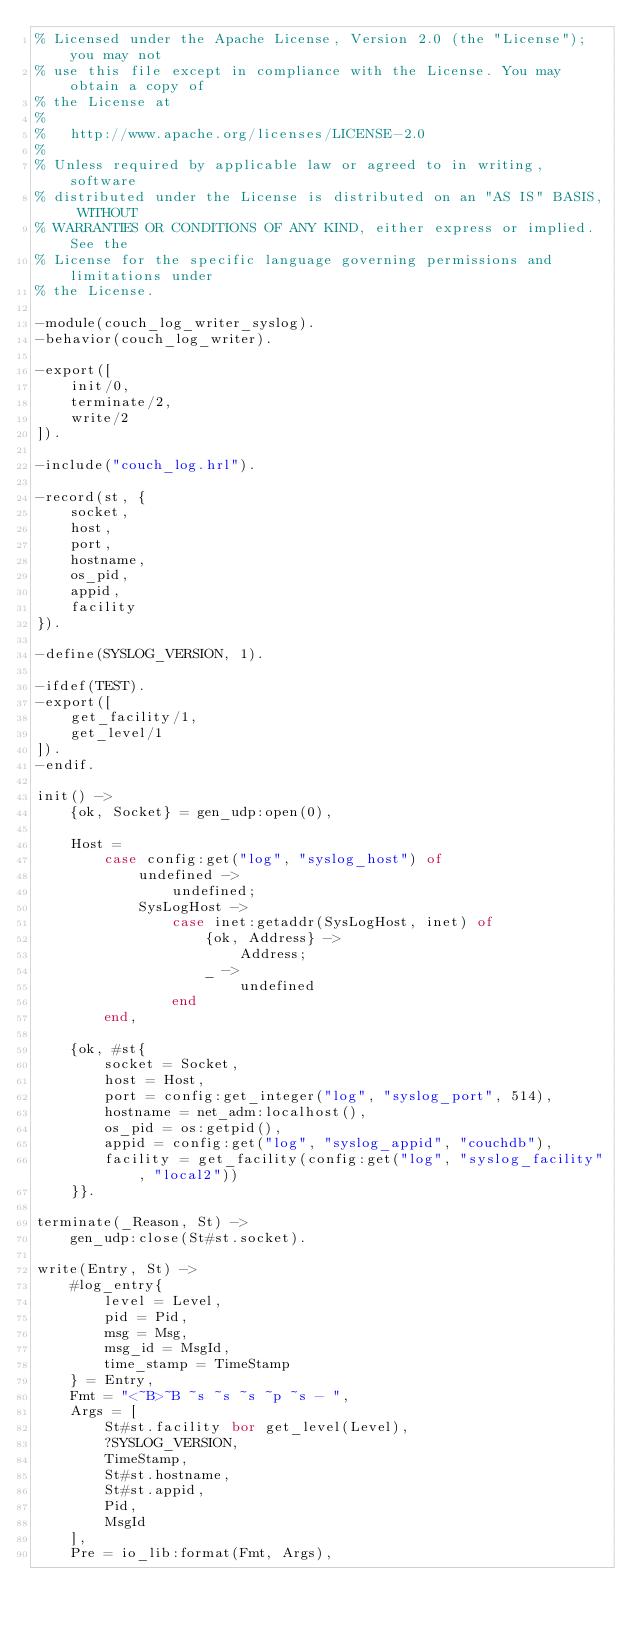Convert code to text. <code><loc_0><loc_0><loc_500><loc_500><_Erlang_>% Licensed under the Apache License, Version 2.0 (the "License"); you may not
% use this file except in compliance with the License. You may obtain a copy of
% the License at
%
%   http://www.apache.org/licenses/LICENSE-2.0
%
% Unless required by applicable law or agreed to in writing, software
% distributed under the License is distributed on an "AS IS" BASIS, WITHOUT
% WARRANTIES OR CONDITIONS OF ANY KIND, either express or implied. See the
% License for the specific language governing permissions and limitations under
% the License.

-module(couch_log_writer_syslog).
-behavior(couch_log_writer).

-export([
    init/0,
    terminate/2,
    write/2
]).

-include("couch_log.hrl").

-record(st, {
    socket,
    host,
    port,
    hostname,
    os_pid,
    appid,
    facility
}).

-define(SYSLOG_VERSION, 1).

-ifdef(TEST).
-export([
    get_facility/1,
    get_level/1
]).
-endif.

init() ->
    {ok, Socket} = gen_udp:open(0),

    Host =
        case config:get("log", "syslog_host") of
            undefined ->
                undefined;
            SysLogHost ->
                case inet:getaddr(SysLogHost, inet) of
                    {ok, Address} ->
                        Address;
                    _ ->
                        undefined
                end
        end,

    {ok, #st{
        socket = Socket,
        host = Host,
        port = config:get_integer("log", "syslog_port", 514),
        hostname = net_adm:localhost(),
        os_pid = os:getpid(),
        appid = config:get("log", "syslog_appid", "couchdb"),
        facility = get_facility(config:get("log", "syslog_facility", "local2"))
    }}.

terminate(_Reason, St) ->
    gen_udp:close(St#st.socket).

write(Entry, St) ->
    #log_entry{
        level = Level,
        pid = Pid,
        msg = Msg,
        msg_id = MsgId,
        time_stamp = TimeStamp
    } = Entry,
    Fmt = "<~B>~B ~s ~s ~s ~p ~s - ",
    Args = [
        St#st.facility bor get_level(Level),
        ?SYSLOG_VERSION,
        TimeStamp,
        St#st.hostname,
        St#st.appid,
        Pid,
        MsgId
    ],
    Pre = io_lib:format(Fmt, Args),</code> 